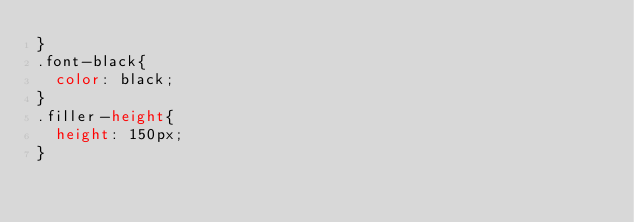Convert code to text. <code><loc_0><loc_0><loc_500><loc_500><_CSS_>}
.font-black{
	color: black;
}
.filler-height{
	height: 150px;
}</code> 